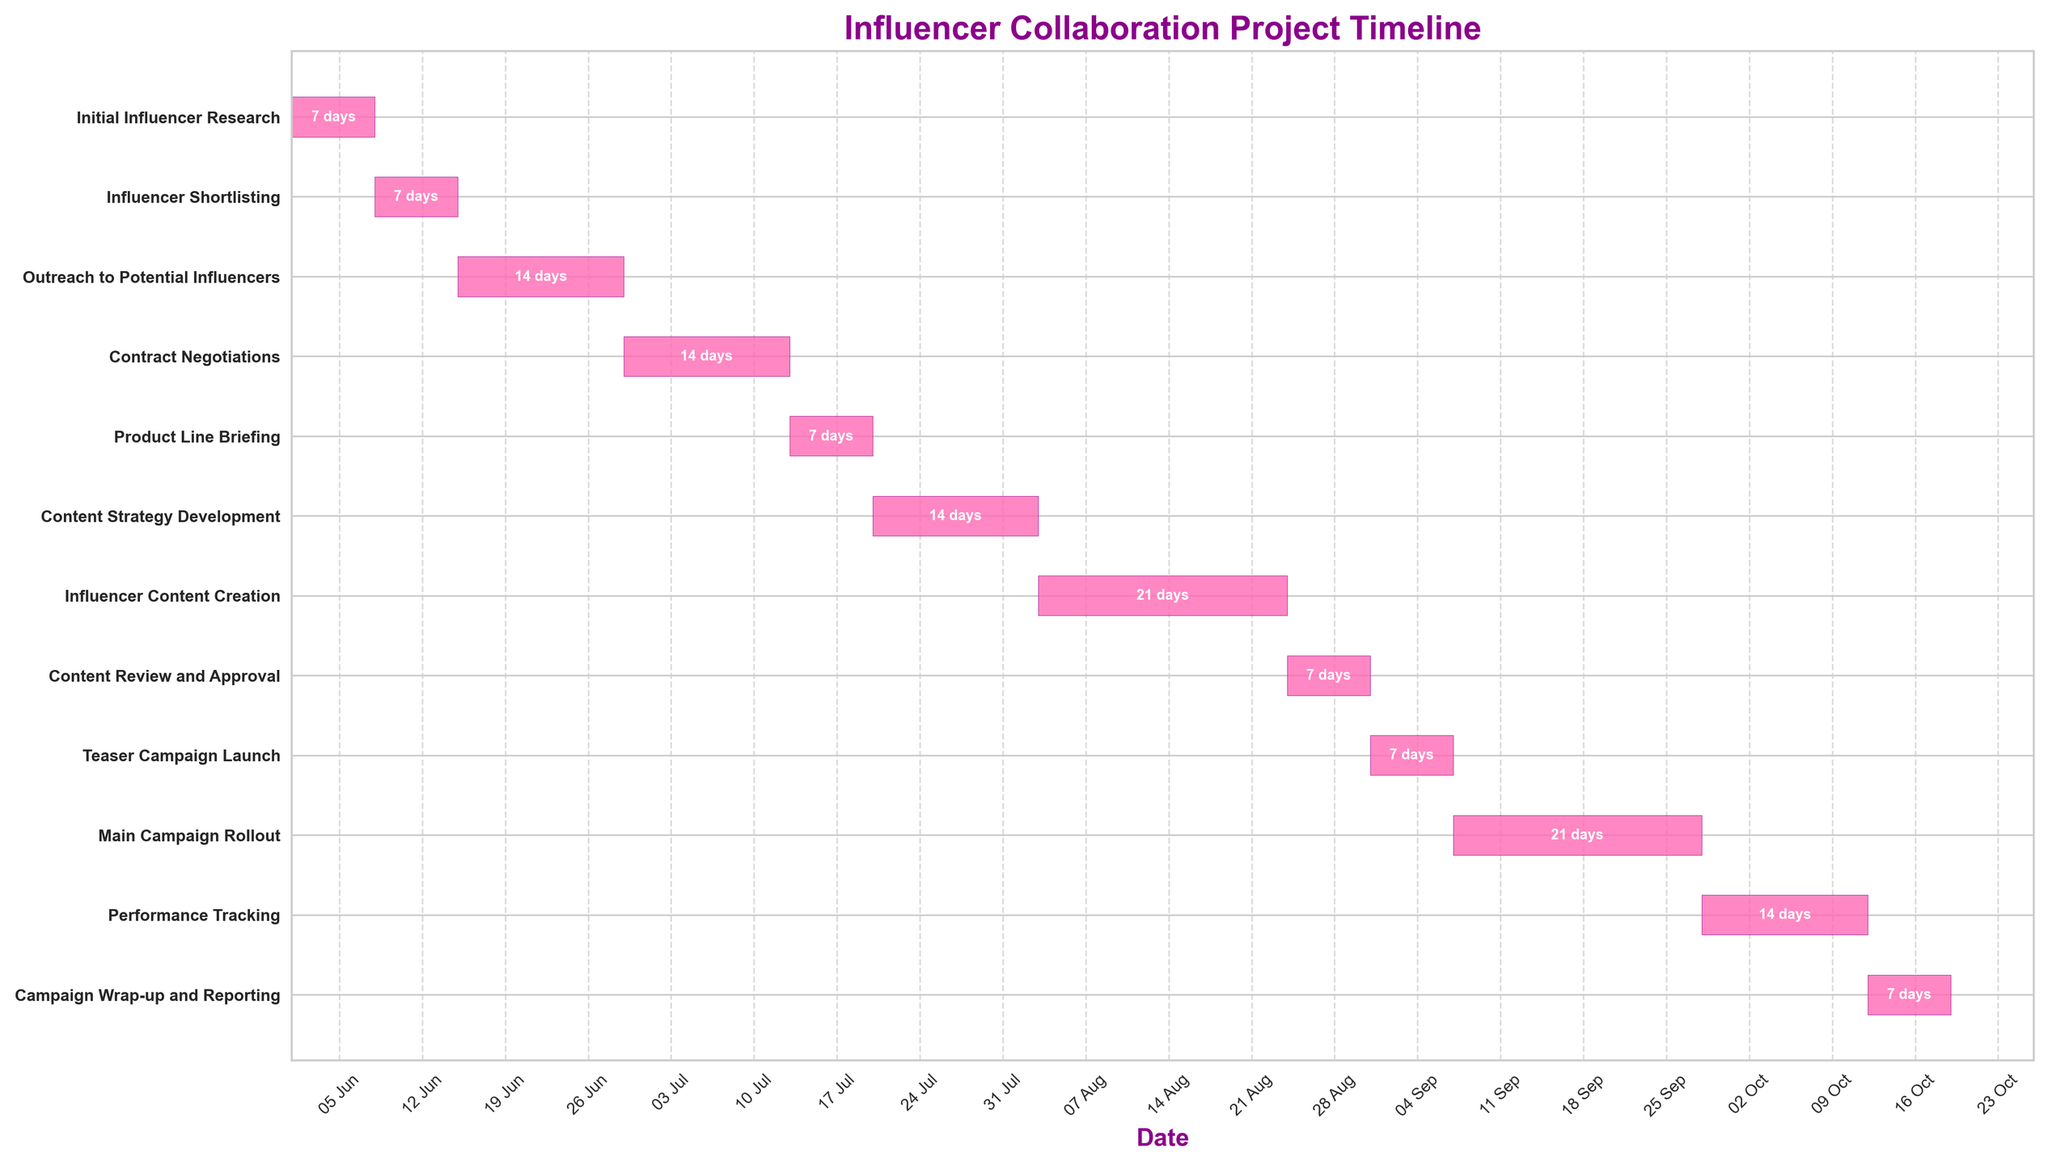What is the title of the chart? The title of the chart can be found at the top in a prominent font size and style. Look for a descriptive text that summarizes the entire figure.
Answer: Influencer Collaboration Project Timeline What are the start and end dates for the "Initial Influencer Research" task? The start and end dates can be found by locating the "Initial Influencer Research" task on the vertical axis and checking the corresponding bar's horizontal boundaries.
Answer: June 1, 2023 - June 7, 2023 How long is the "Outreach to Potential Influencers" task? Find the "Outreach to Potential Influencers" task in the chart, and check the duration label in the middle of its bar.
Answer: 14 days Which task has the longest duration? Compare the length of all task bars, either visually or by checking the duration labels, and identify the task with the longest duration.
Answer: Main Campaign Rollout What is the duration of the "Product Line Briefing" task compared to "Contract Negotiations"? Locate both tasks on the vertical axis and compare their corresponding bars' durations by checking the duration labels.
Answer: Product Line Briefing: 7 days; Contract Negotiations: 14 days Which task starts immediately after "Influencer Shortlisting"? Identify the task bar that is adjacent and to the right of the "Influencer Shortlisting" task bar.
Answer: Outreach to Potential Influencers When does the "Main Campaign Rollout" start and end? Look for the "Main Campaign Rollout" task on the vertical axis and check the start and end dates at the horizontal boundaries of its bar.
Answer: September 7, 2023 - September 27, 2023 How many days are dedicated to the "Content Review and Approval" process? Find the "Content Review and Approval" task and check the duration label placed within its respective bar.
Answer: 7 days What is the total duration from the start of "Initial Influencer Research" to the end of "Campaign Wrap-up and Reporting"? Calculate the duration from the start date of the "Initial Influencer Research" to the end date of the "Campaign Wrap-up and Reporting" by subtracting the earliest date from the latest date.
Answer: 140 days Which two tasks overlap in the month of August? Examine the tasks listed and find which two or more tasks share common dates through the month of August by looking at their horizontal bars.
Answer: Content Strategy Development and Influencer Content Creation 